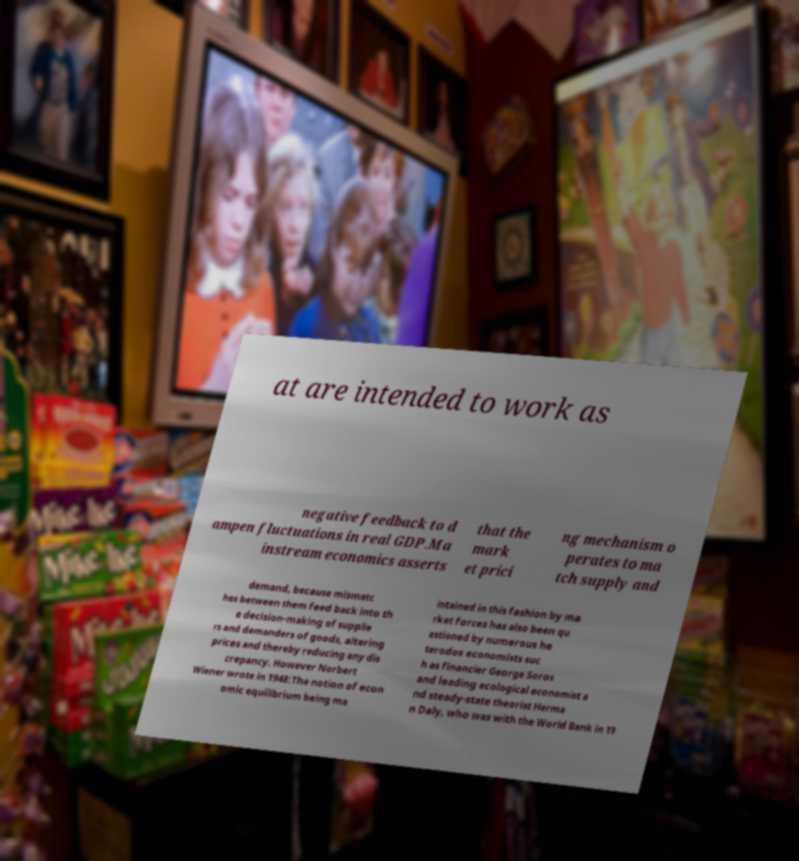I need the written content from this picture converted into text. Can you do that? at are intended to work as negative feedback to d ampen fluctuations in real GDP.Ma instream economics asserts that the mark et prici ng mechanism o perates to ma tch supply and demand, because mismatc hes between them feed back into th e decision-making of supplie rs and demanders of goods, altering prices and thereby reducing any dis crepancy. However Norbert Wiener wrote in 1948:The notion of econ omic equilibrium being ma intained in this fashion by ma rket forces has also been qu estioned by numerous he terodox economists suc h as financier George Soros and leading ecological economist a nd steady-state theorist Herma n Daly, who was with the World Bank in 19 